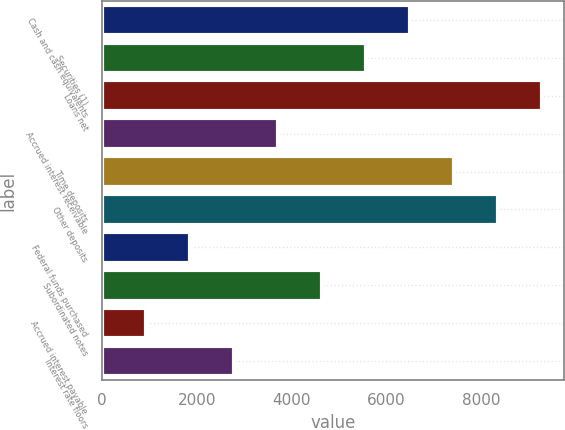Convert chart. <chart><loc_0><loc_0><loc_500><loc_500><bar_chart><fcel>Cash and cash equivalents<fcel>Securities (1)<fcel>Loans net<fcel>Accrued interest receivable<fcel>Time deposits<fcel>Other deposits<fcel>Federal funds purchased<fcel>Subordinated notes<fcel>Accrued interest payable<fcel>Interest rate floors<nl><fcel>6508.45<fcel>5578.7<fcel>9297.7<fcel>3719.2<fcel>7438.2<fcel>8367.95<fcel>1859.7<fcel>4648.95<fcel>929.95<fcel>2789.45<nl></chart> 